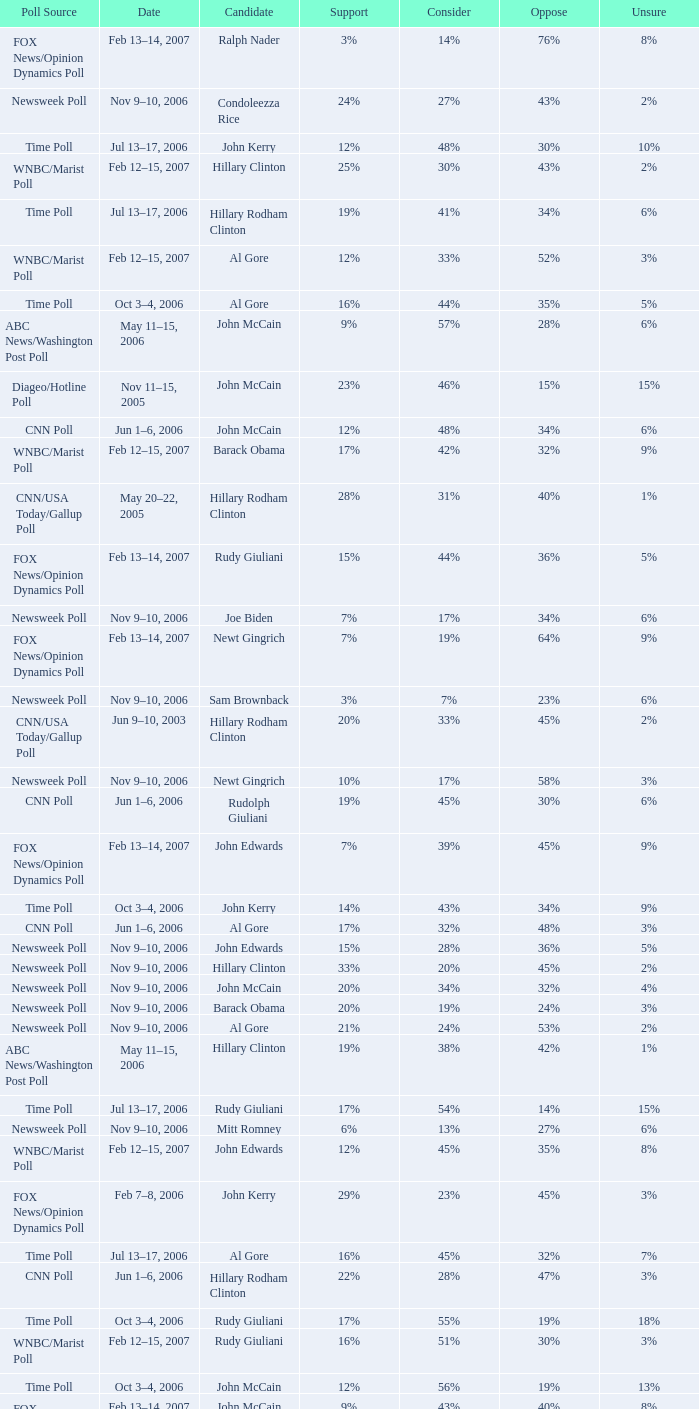What percentage of people were opposed to the candidate based on the WNBC/Marist poll that showed 8% of people were unsure? 35%. 